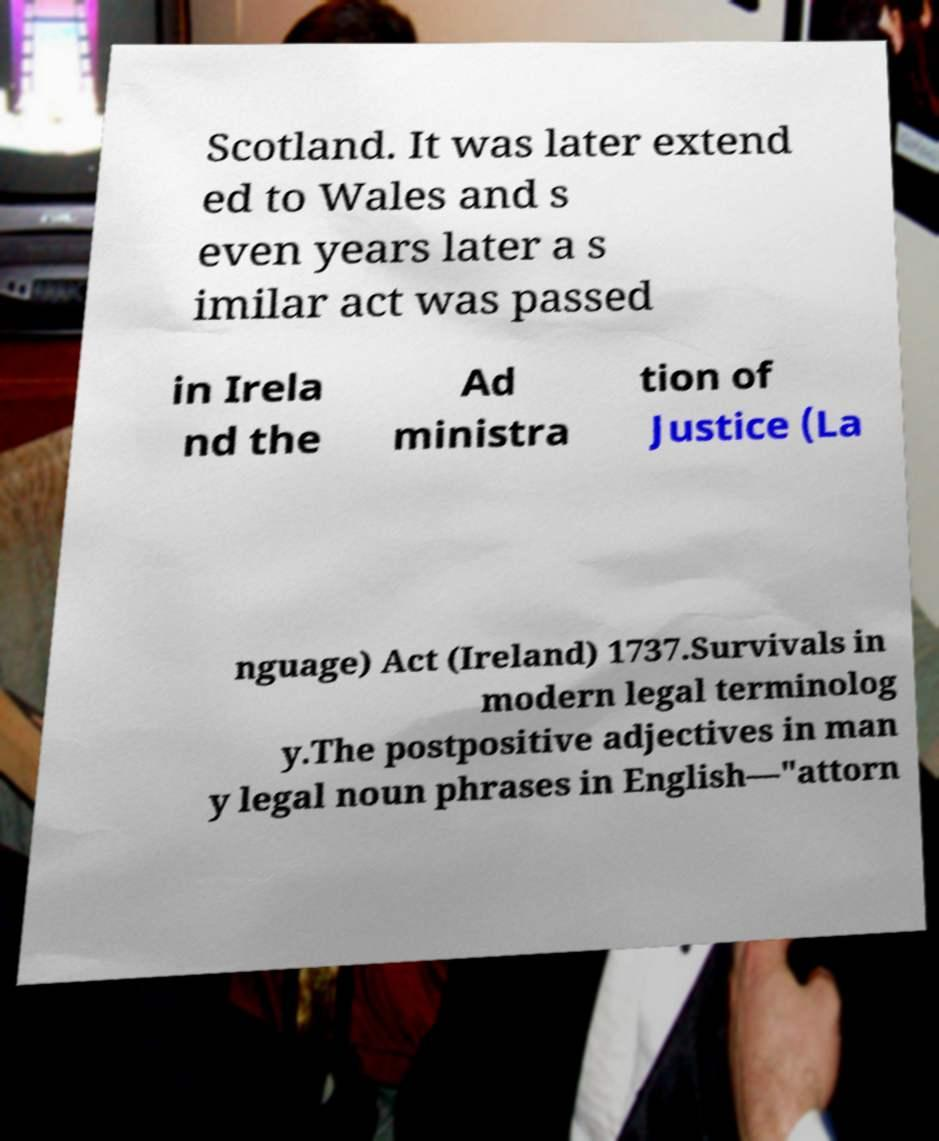There's text embedded in this image that I need extracted. Can you transcribe it verbatim? Scotland. It was later extend ed to Wales and s even years later a s imilar act was passed in Irela nd the Ad ministra tion of Justice (La nguage) Act (Ireland) 1737.Survivals in modern legal terminolog y.The postpositive adjectives in man y legal noun phrases in English—"attorn 